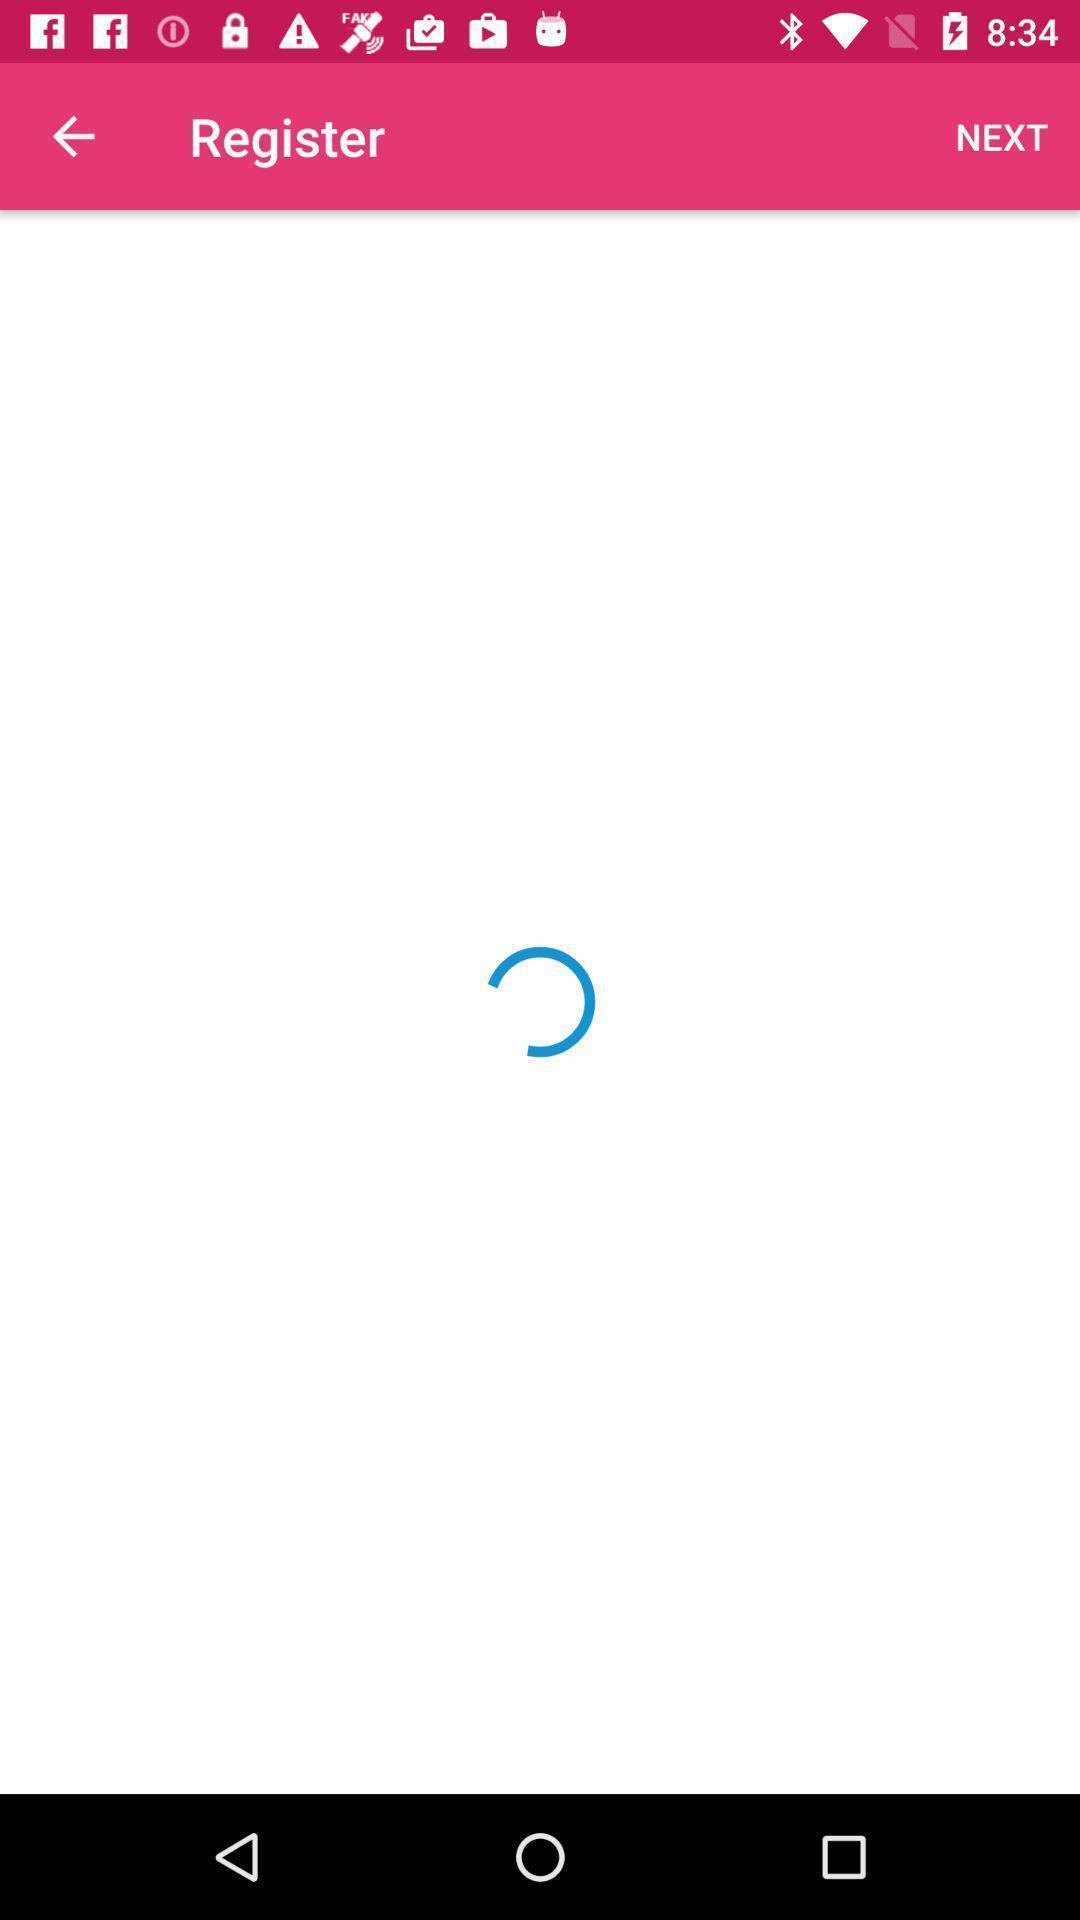What is the overall content of this screenshot? Register page. 